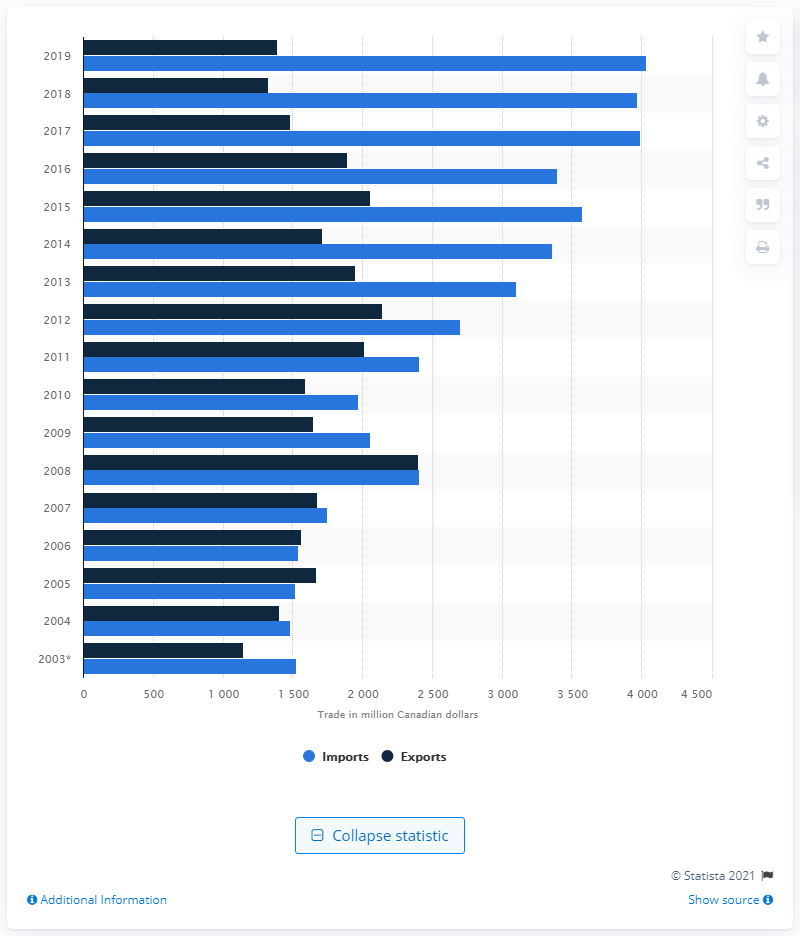Indicate a few pertinent items in this graphic. In 2019, the value of Canadian exports was CAD 1,393. 